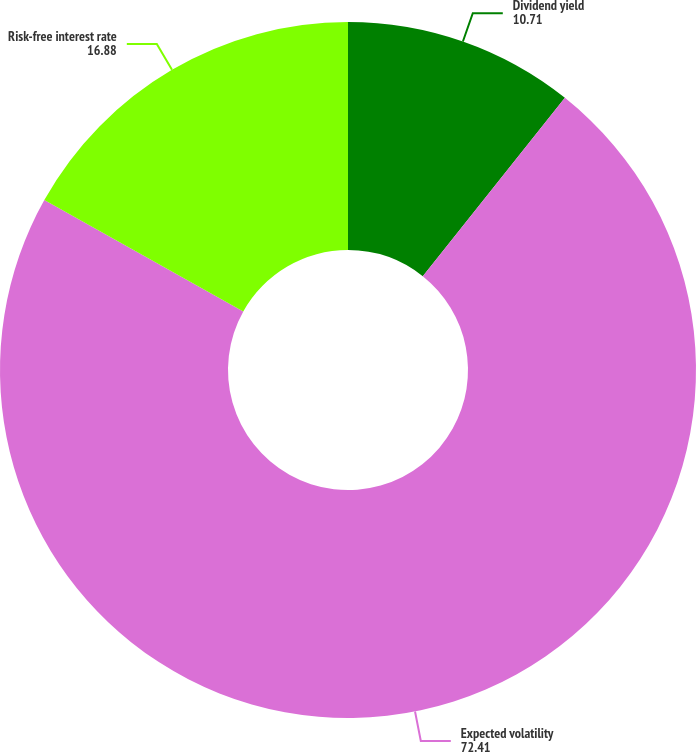Convert chart. <chart><loc_0><loc_0><loc_500><loc_500><pie_chart><fcel>Dividend yield<fcel>Expected volatility<fcel>Risk-free interest rate<nl><fcel>10.71%<fcel>72.41%<fcel>16.88%<nl></chart> 